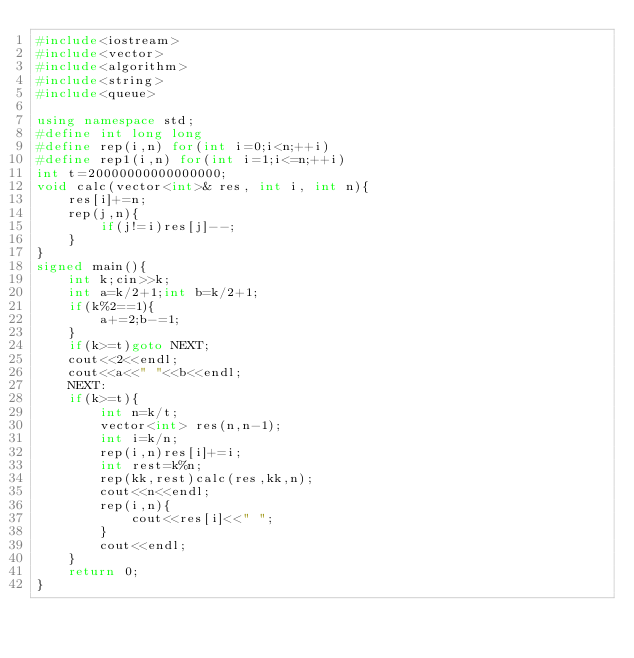<code> <loc_0><loc_0><loc_500><loc_500><_C++_>#include<iostream>
#include<vector>
#include<algorithm>
#include<string>
#include<queue>

using namespace std;
#define int long long
#define rep(i,n) for(int i=0;i<n;++i)
#define rep1(i,n) for(int i=1;i<=n;++i)
int t=20000000000000000;
void calc(vector<int>& res, int i, int n){
    res[i]+=n;
    rep(j,n){
        if(j!=i)res[j]--;
    }
}
signed main(){
    int k;cin>>k;
    int a=k/2+1;int b=k/2+1;
    if(k%2==1){
        a+=2;b-=1;
    }
    if(k>=t)goto NEXT;
    cout<<2<<endl;
    cout<<a<<" "<<b<<endl;
    NEXT:
    if(k>=t){
        int n=k/t;
        vector<int> res(n,n-1);
        int i=k/n;
        rep(i,n)res[i]+=i;
        int rest=k%n;
        rep(kk,rest)calc(res,kk,n);
        cout<<n<<endl;
        rep(i,n){
            cout<<res[i]<<" ";
        }
        cout<<endl;
    }
    return 0;
}</code> 